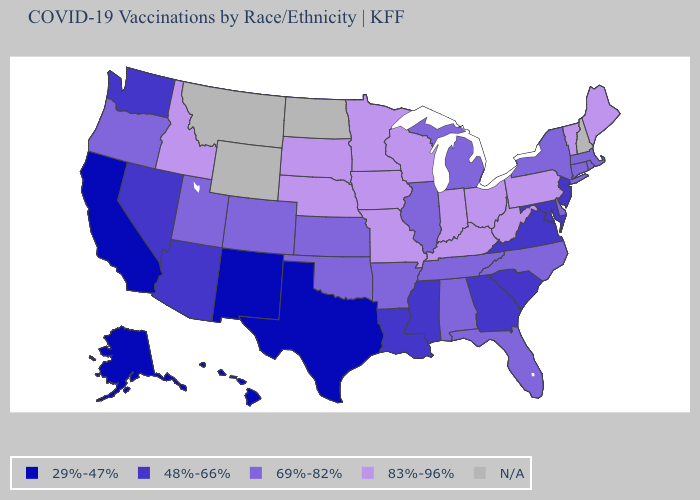What is the value of Illinois?
Give a very brief answer. 69%-82%. Among the states that border California , which have the lowest value?
Keep it brief. Arizona, Nevada. Does Kentucky have the highest value in the USA?
Short answer required. Yes. What is the value of Utah?
Keep it brief. 69%-82%. Does Ohio have the highest value in the MidWest?
Quick response, please. Yes. Does California have the highest value in the USA?
Quick response, please. No. Does Alaska have the lowest value in the West?
Write a very short answer. Yes. How many symbols are there in the legend?
Give a very brief answer. 5. Name the states that have a value in the range 48%-66%?
Quick response, please. Arizona, Georgia, Louisiana, Maryland, Mississippi, Nevada, New Jersey, South Carolina, Virginia, Washington. What is the value of South Carolina?
Answer briefly. 48%-66%. Does the first symbol in the legend represent the smallest category?
Answer briefly. Yes. Does Rhode Island have the highest value in the USA?
Be succinct. No. How many symbols are there in the legend?
Answer briefly. 5. Which states hav the highest value in the West?
Short answer required. Idaho. 